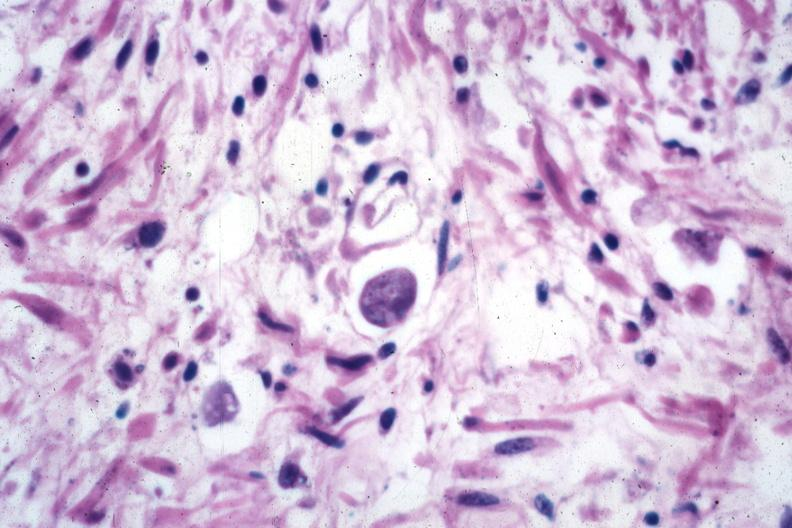what is present?
Answer the question using a single word or phrase. Gastrointestinal 